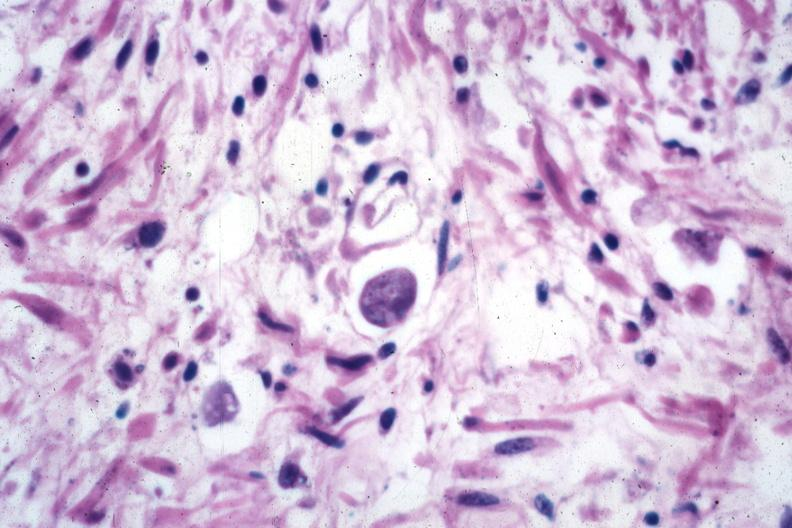what is present?
Answer the question using a single word or phrase. Gastrointestinal 